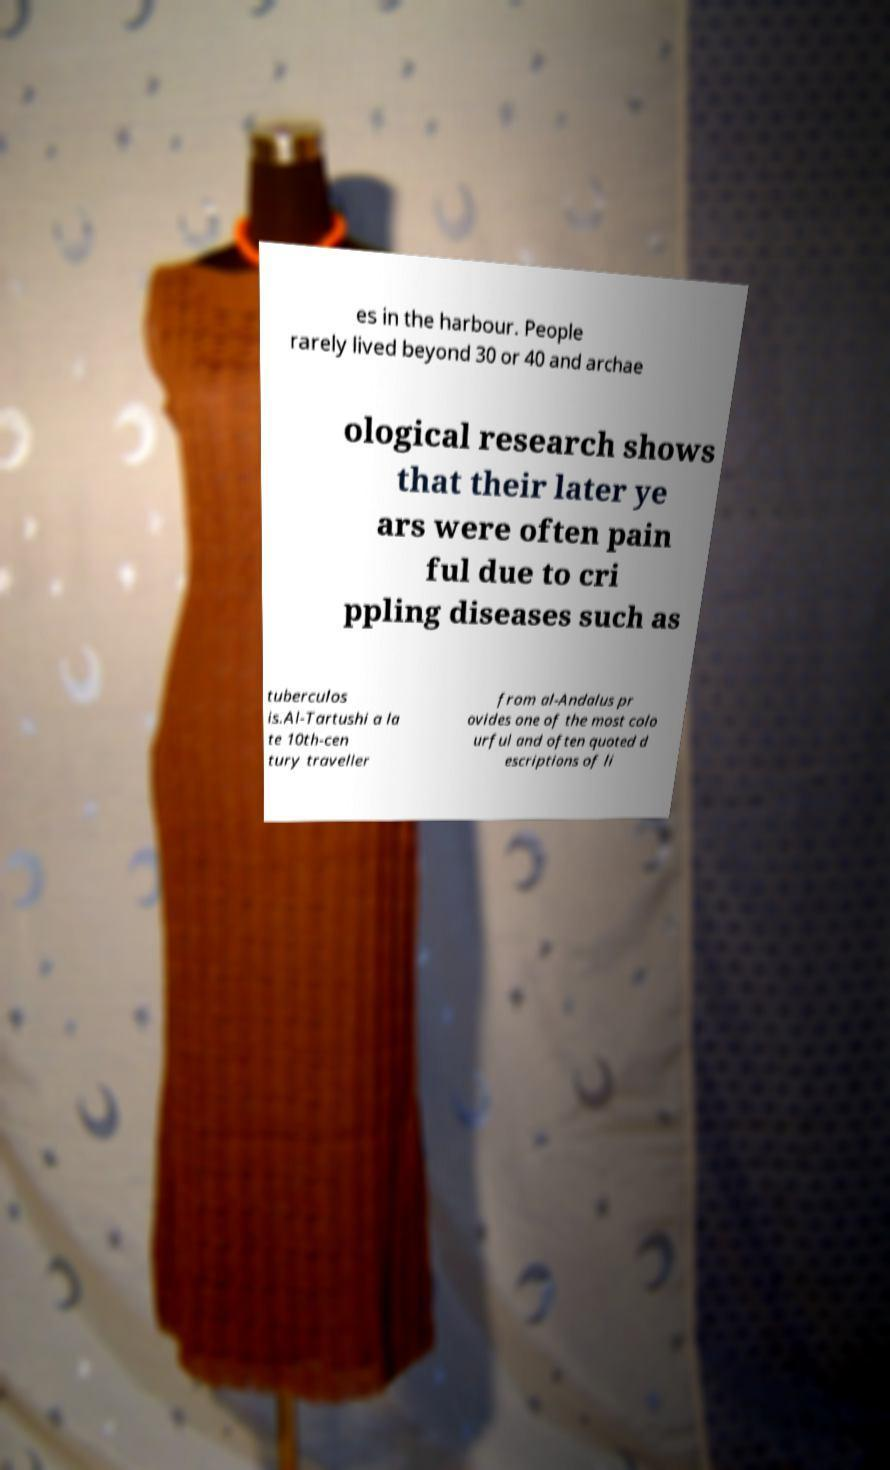Could you assist in decoding the text presented in this image and type it out clearly? es in the harbour. People rarely lived beyond 30 or 40 and archae ological research shows that their later ye ars were often pain ful due to cri ppling diseases such as tuberculos is.Al-Tartushi a la te 10th-cen tury traveller from al-Andalus pr ovides one of the most colo urful and often quoted d escriptions of li 